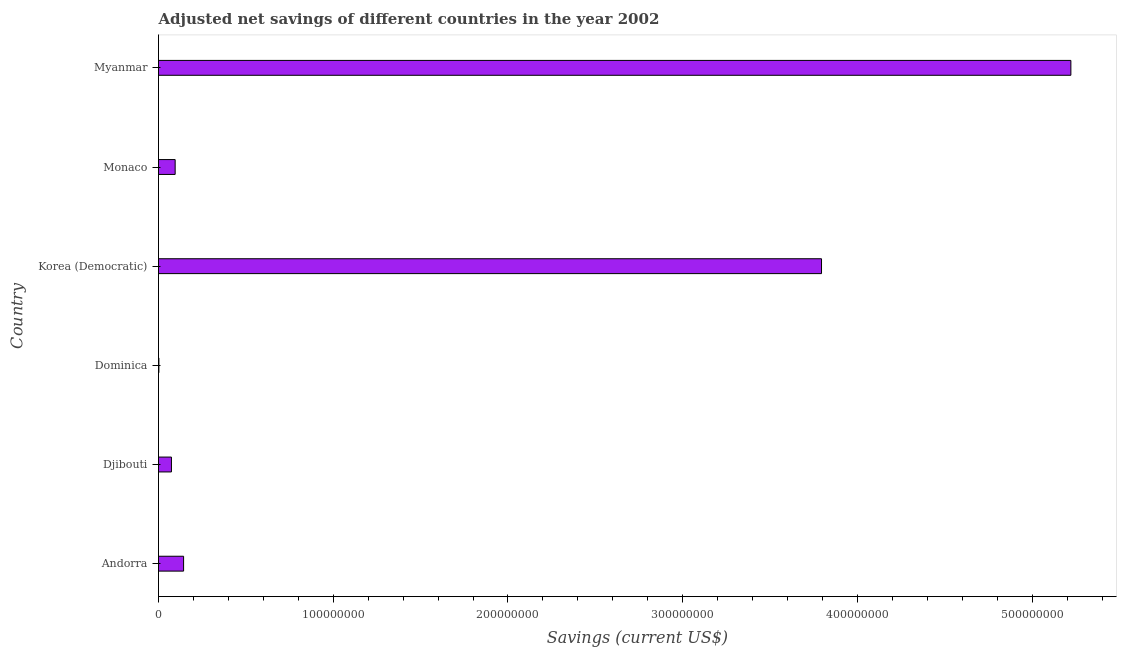Does the graph contain any zero values?
Provide a succinct answer. No. What is the title of the graph?
Offer a very short reply. Adjusted net savings of different countries in the year 2002. What is the label or title of the X-axis?
Ensure brevity in your answer.  Savings (current US$). What is the adjusted net savings in Andorra?
Provide a short and direct response. 1.44e+07. Across all countries, what is the maximum adjusted net savings?
Provide a short and direct response. 5.22e+08. Across all countries, what is the minimum adjusted net savings?
Offer a very short reply. 2.14e+05. In which country was the adjusted net savings maximum?
Your answer should be very brief. Myanmar. In which country was the adjusted net savings minimum?
Your response must be concise. Dominica. What is the sum of the adjusted net savings?
Make the answer very short. 9.33e+08. What is the difference between the adjusted net savings in Korea (Democratic) and Myanmar?
Your response must be concise. -1.43e+08. What is the average adjusted net savings per country?
Ensure brevity in your answer.  1.56e+08. What is the median adjusted net savings?
Keep it short and to the point. 1.19e+07. What is the ratio of the adjusted net savings in Andorra to that in Djibouti?
Offer a terse response. 1.94. Is the adjusted net savings in Monaco less than that in Myanmar?
Your answer should be very brief. Yes. Is the difference between the adjusted net savings in Djibouti and Dominica greater than the difference between any two countries?
Keep it short and to the point. No. What is the difference between the highest and the second highest adjusted net savings?
Your answer should be compact. 1.43e+08. What is the difference between the highest and the lowest adjusted net savings?
Your answer should be compact. 5.22e+08. Are all the bars in the graph horizontal?
Provide a succinct answer. Yes. What is the difference between two consecutive major ticks on the X-axis?
Ensure brevity in your answer.  1.00e+08. Are the values on the major ticks of X-axis written in scientific E-notation?
Make the answer very short. No. What is the Savings (current US$) of Andorra?
Provide a short and direct response. 1.44e+07. What is the Savings (current US$) in Djibouti?
Your answer should be very brief. 7.39e+06. What is the Savings (current US$) in Dominica?
Keep it short and to the point. 2.14e+05. What is the Savings (current US$) of Korea (Democratic)?
Provide a succinct answer. 3.79e+08. What is the Savings (current US$) in Monaco?
Give a very brief answer. 9.52e+06. What is the Savings (current US$) of Myanmar?
Provide a short and direct response. 5.22e+08. What is the difference between the Savings (current US$) in Andorra and Djibouti?
Make the answer very short. 6.96e+06. What is the difference between the Savings (current US$) in Andorra and Dominica?
Your answer should be very brief. 1.41e+07. What is the difference between the Savings (current US$) in Andorra and Korea (Democratic)?
Your answer should be compact. -3.65e+08. What is the difference between the Savings (current US$) in Andorra and Monaco?
Offer a very short reply. 4.83e+06. What is the difference between the Savings (current US$) in Andorra and Myanmar?
Give a very brief answer. -5.08e+08. What is the difference between the Savings (current US$) in Djibouti and Dominica?
Keep it short and to the point. 7.18e+06. What is the difference between the Savings (current US$) in Djibouti and Korea (Democratic)?
Your answer should be compact. -3.72e+08. What is the difference between the Savings (current US$) in Djibouti and Monaco?
Your response must be concise. -2.13e+06. What is the difference between the Savings (current US$) in Djibouti and Myanmar?
Offer a terse response. -5.15e+08. What is the difference between the Savings (current US$) in Dominica and Korea (Democratic)?
Give a very brief answer. -3.79e+08. What is the difference between the Savings (current US$) in Dominica and Monaco?
Your answer should be very brief. -9.31e+06. What is the difference between the Savings (current US$) in Dominica and Myanmar?
Your response must be concise. -5.22e+08. What is the difference between the Savings (current US$) in Korea (Democratic) and Monaco?
Keep it short and to the point. 3.70e+08. What is the difference between the Savings (current US$) in Korea (Democratic) and Myanmar?
Provide a succinct answer. -1.43e+08. What is the difference between the Savings (current US$) in Monaco and Myanmar?
Your response must be concise. -5.13e+08. What is the ratio of the Savings (current US$) in Andorra to that in Djibouti?
Keep it short and to the point. 1.94. What is the ratio of the Savings (current US$) in Andorra to that in Dominica?
Ensure brevity in your answer.  67.14. What is the ratio of the Savings (current US$) in Andorra to that in Korea (Democratic)?
Make the answer very short. 0.04. What is the ratio of the Savings (current US$) in Andorra to that in Monaco?
Your response must be concise. 1.51. What is the ratio of the Savings (current US$) in Andorra to that in Myanmar?
Offer a terse response. 0.03. What is the ratio of the Savings (current US$) in Djibouti to that in Dominica?
Give a very brief answer. 34.59. What is the ratio of the Savings (current US$) in Djibouti to that in Korea (Democratic)?
Offer a very short reply. 0.02. What is the ratio of the Savings (current US$) in Djibouti to that in Monaco?
Provide a succinct answer. 0.78. What is the ratio of the Savings (current US$) in Djibouti to that in Myanmar?
Your response must be concise. 0.01. What is the ratio of the Savings (current US$) in Dominica to that in Korea (Democratic)?
Your response must be concise. 0. What is the ratio of the Savings (current US$) in Dominica to that in Monaco?
Your response must be concise. 0.02. What is the ratio of the Savings (current US$) in Korea (Democratic) to that in Monaco?
Ensure brevity in your answer.  39.84. What is the ratio of the Savings (current US$) in Korea (Democratic) to that in Myanmar?
Your answer should be compact. 0.73. What is the ratio of the Savings (current US$) in Monaco to that in Myanmar?
Keep it short and to the point. 0.02. 